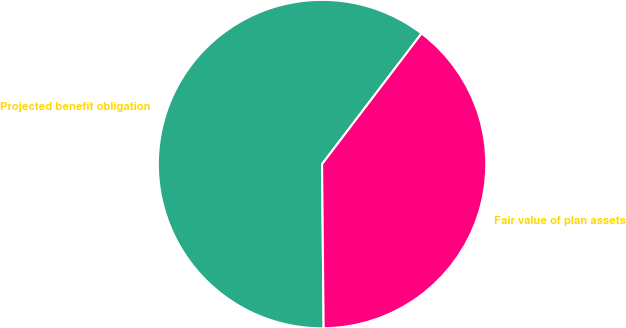Convert chart. <chart><loc_0><loc_0><loc_500><loc_500><pie_chart><fcel>Projected benefit obligation<fcel>Fair value of plan assets<nl><fcel>60.51%<fcel>39.49%<nl></chart> 